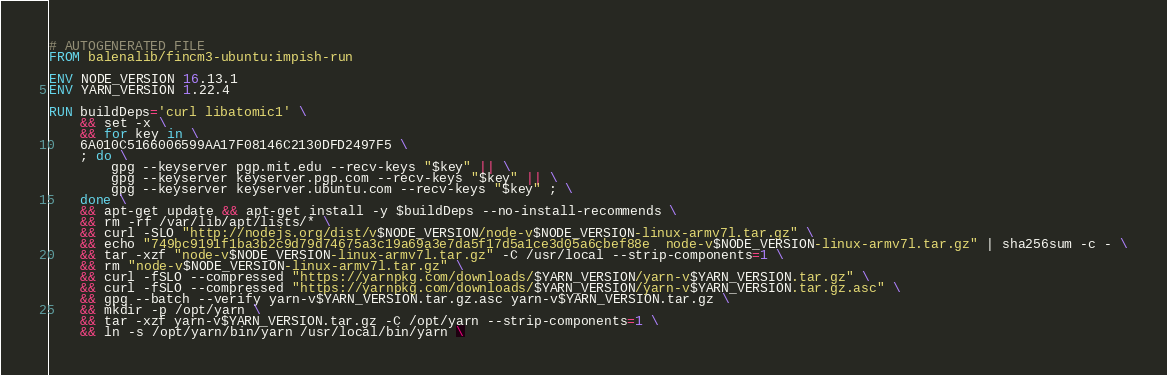<code> <loc_0><loc_0><loc_500><loc_500><_Dockerfile_># AUTOGENERATED FILE
FROM balenalib/fincm3-ubuntu:impish-run

ENV NODE_VERSION 16.13.1
ENV YARN_VERSION 1.22.4

RUN buildDeps='curl libatomic1' \
	&& set -x \
	&& for key in \
	6A010C5166006599AA17F08146C2130DFD2497F5 \
	; do \
		gpg --keyserver pgp.mit.edu --recv-keys "$key" || \
		gpg --keyserver keyserver.pgp.com --recv-keys "$key" || \
		gpg --keyserver keyserver.ubuntu.com --recv-keys "$key" ; \
	done \
	&& apt-get update && apt-get install -y $buildDeps --no-install-recommends \
	&& rm -rf /var/lib/apt/lists/* \
	&& curl -SLO "http://nodejs.org/dist/v$NODE_VERSION/node-v$NODE_VERSION-linux-armv7l.tar.gz" \
	&& echo "749bc9191f1ba3b2c9d79d74675a3c19a69a3e7da5f17d5a1ce3d05a6cbef88e  node-v$NODE_VERSION-linux-armv7l.tar.gz" | sha256sum -c - \
	&& tar -xzf "node-v$NODE_VERSION-linux-armv7l.tar.gz" -C /usr/local --strip-components=1 \
	&& rm "node-v$NODE_VERSION-linux-armv7l.tar.gz" \
	&& curl -fSLO --compressed "https://yarnpkg.com/downloads/$YARN_VERSION/yarn-v$YARN_VERSION.tar.gz" \
	&& curl -fSLO --compressed "https://yarnpkg.com/downloads/$YARN_VERSION/yarn-v$YARN_VERSION.tar.gz.asc" \
	&& gpg --batch --verify yarn-v$YARN_VERSION.tar.gz.asc yarn-v$YARN_VERSION.tar.gz \
	&& mkdir -p /opt/yarn \
	&& tar -xzf yarn-v$YARN_VERSION.tar.gz -C /opt/yarn --strip-components=1 \
	&& ln -s /opt/yarn/bin/yarn /usr/local/bin/yarn \</code> 